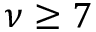Convert formula to latex. <formula><loc_0><loc_0><loc_500><loc_500>\nu \geq 7</formula> 